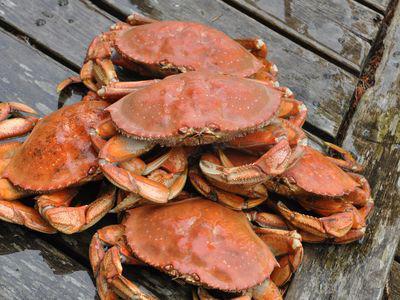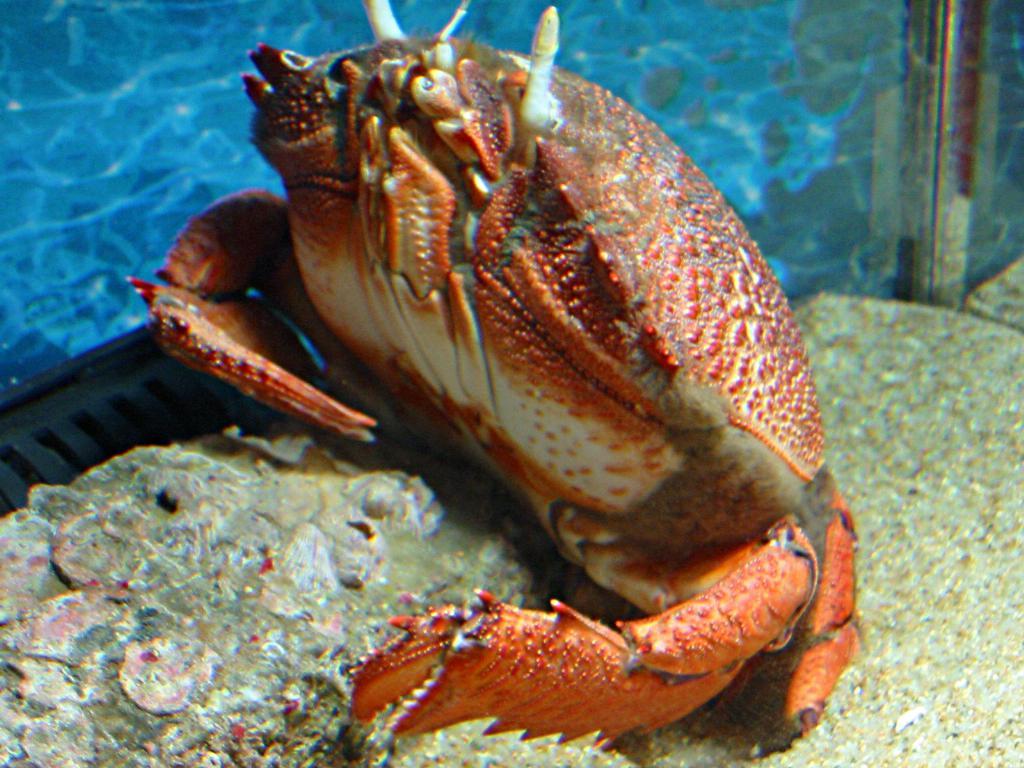The first image is the image on the left, the second image is the image on the right. Assess this claim about the two images: "The left image shows a pile of forward-facing reddish-orange shell-side up crabs without distinctive spots or a visible container.". Correct or not? Answer yes or no. Yes. The first image is the image on the left, the second image is the image on the right. Assess this claim about the two images: "At least one of the pictures shows crabs being carried in a round bucket.". Correct or not? Answer yes or no. No. 